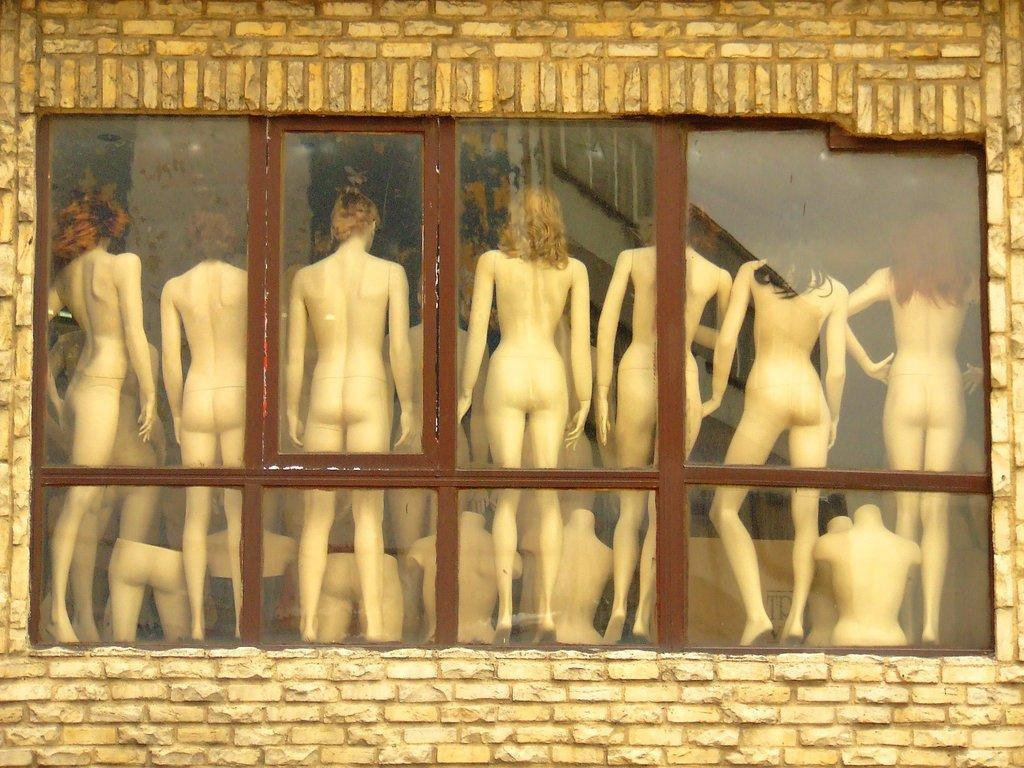What is one of the main features in the image? There is a wall in the image. What can be seen through the glass in the image? Mannequins are visible through the glass in the image. What type of rail can be seen in the image? There is no rail present in the image. Is there a boy interacting with the mannequins in the image? There is no boy present in the image. 